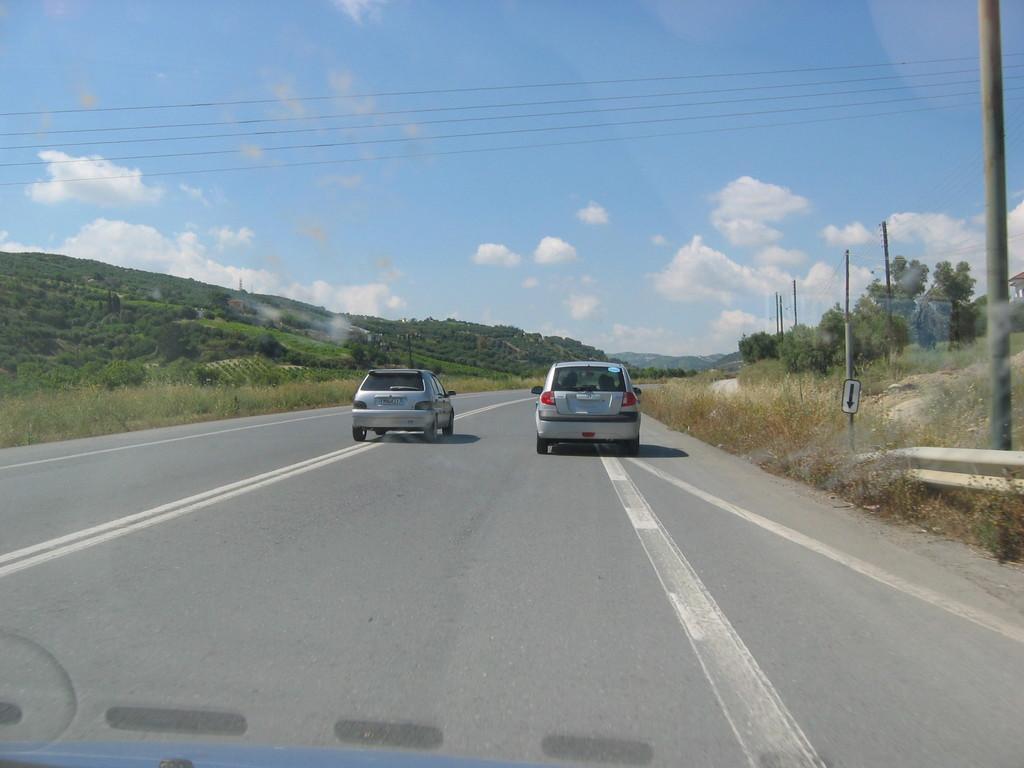Could you give a brief overview of what you see in this image? In this image we can see some cars on the road. We can also see some grass, piles, a sign board, wires, a group of trees on the hills and the sky which looks cloudy. 